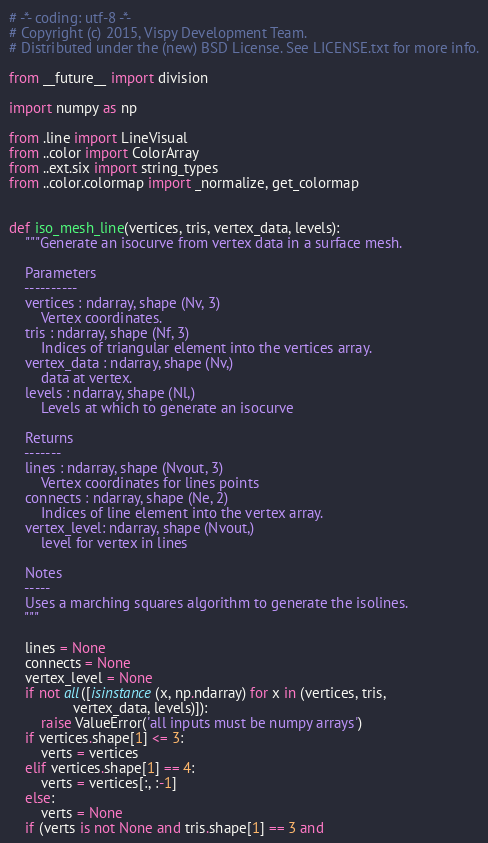Convert code to text. <code><loc_0><loc_0><loc_500><loc_500><_Python_># -*- coding: utf-8 -*-
# Copyright (c) 2015, Vispy Development Team.
# Distributed under the (new) BSD License. See LICENSE.txt for more info.

from __future__ import division

import numpy as np

from .line import LineVisual
from ..color import ColorArray
from ..ext.six import string_types
from ..color.colormap import _normalize, get_colormap


def iso_mesh_line(vertices, tris, vertex_data, levels):
    """Generate an isocurve from vertex data in a surface mesh.

    Parameters
    ----------
    vertices : ndarray, shape (Nv, 3)
        Vertex coordinates.
    tris : ndarray, shape (Nf, 3)
        Indices of triangular element into the vertices array.
    vertex_data : ndarray, shape (Nv,)
        data at vertex.
    levels : ndarray, shape (Nl,)
        Levels at which to generate an isocurve

    Returns
    -------
    lines : ndarray, shape (Nvout, 3)
        Vertex coordinates for lines points
    connects : ndarray, shape (Ne, 2)
        Indices of line element into the vertex array.
    vertex_level: ndarray, shape (Nvout,)
        level for vertex in lines

    Notes
    -----
    Uses a marching squares algorithm to generate the isolines.
    """

    lines = None
    connects = None
    vertex_level = None
    if not all([isinstance(x, np.ndarray) for x in (vertices, tris,
                vertex_data, levels)]):
        raise ValueError('all inputs must be numpy arrays')
    if vertices.shape[1] <= 3:
        verts = vertices
    elif vertices.shape[1] == 4:
        verts = vertices[:, :-1]
    else:
        verts = None
    if (verts is not None and tris.shape[1] == 3 and</code> 